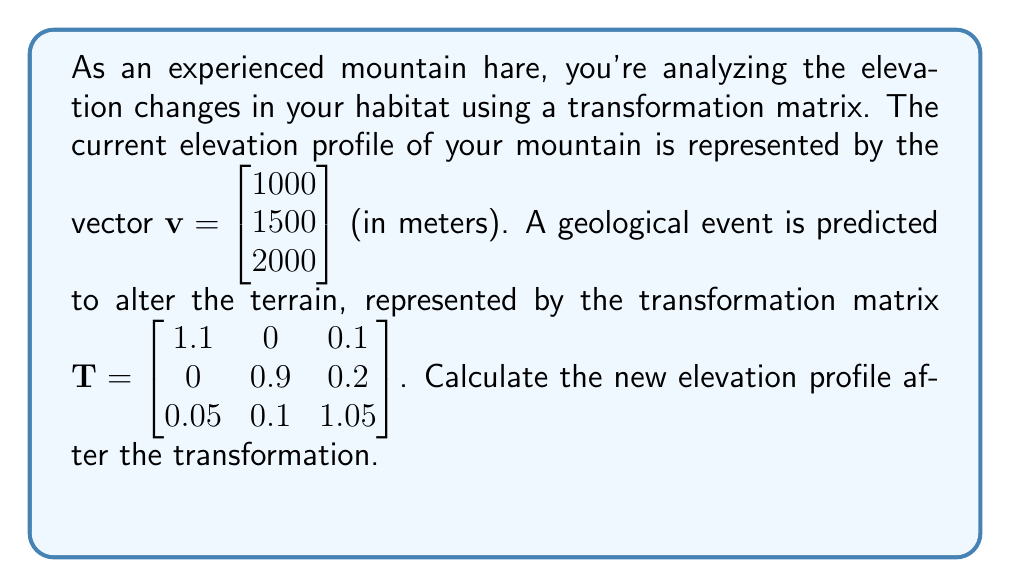Provide a solution to this math problem. To find the new elevation profile, we need to multiply the transformation matrix $\mathbf{T}$ by the original elevation vector $\mathbf{v}$. This is done using matrix multiplication:

$$\mathbf{T} \cdot \mathbf{v} = \begin{bmatrix} 1.1 & 0 & 0.1 \\ 0 & 0.9 & 0.2 \\ 0.05 & 0.1 & 1.05 \end{bmatrix} \cdot \begin{bmatrix} 1000 \\ 1500 \\ 2000 \end{bmatrix}$$

Let's calculate this step by step:

1) For the first element of the resulting vector:
   $$(1.1 \cdot 1000) + (0 \cdot 1500) + (0.1 \cdot 2000) = 1100 + 0 + 200 = 1300$$

2) For the second element:
   $$(0 \cdot 1000) + (0.9 \cdot 1500) + (0.2 \cdot 2000) = 0 + 1350 + 400 = 1750$$

3) For the third element:
   $$(0.05 \cdot 1000) + (0.1 \cdot 1500) + (1.05 \cdot 2000) = 50 + 150 + 2100 = 2300$$

Therefore, the new elevation profile after the transformation is:

$$\begin{bmatrix} 1300 \\ 1750 \\ 2300 \end{bmatrix}$$

This means the lowest point has increased from 1000m to 1300m, the middle point from 1500m to 1750m, and the highest point from 2000m to 2300m.
Answer: $\begin{bmatrix} 1300 \\ 1750 \\ 2300 \end{bmatrix}$ meters 